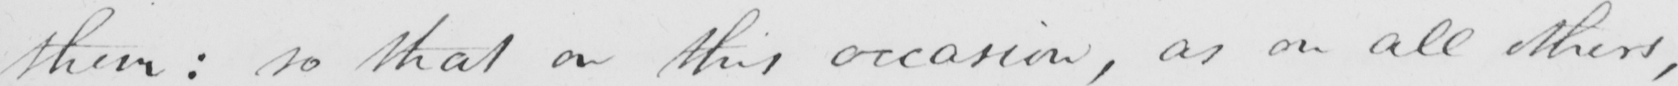Can you read and transcribe this handwriting? them :  so that on this occasion , as on all others , 